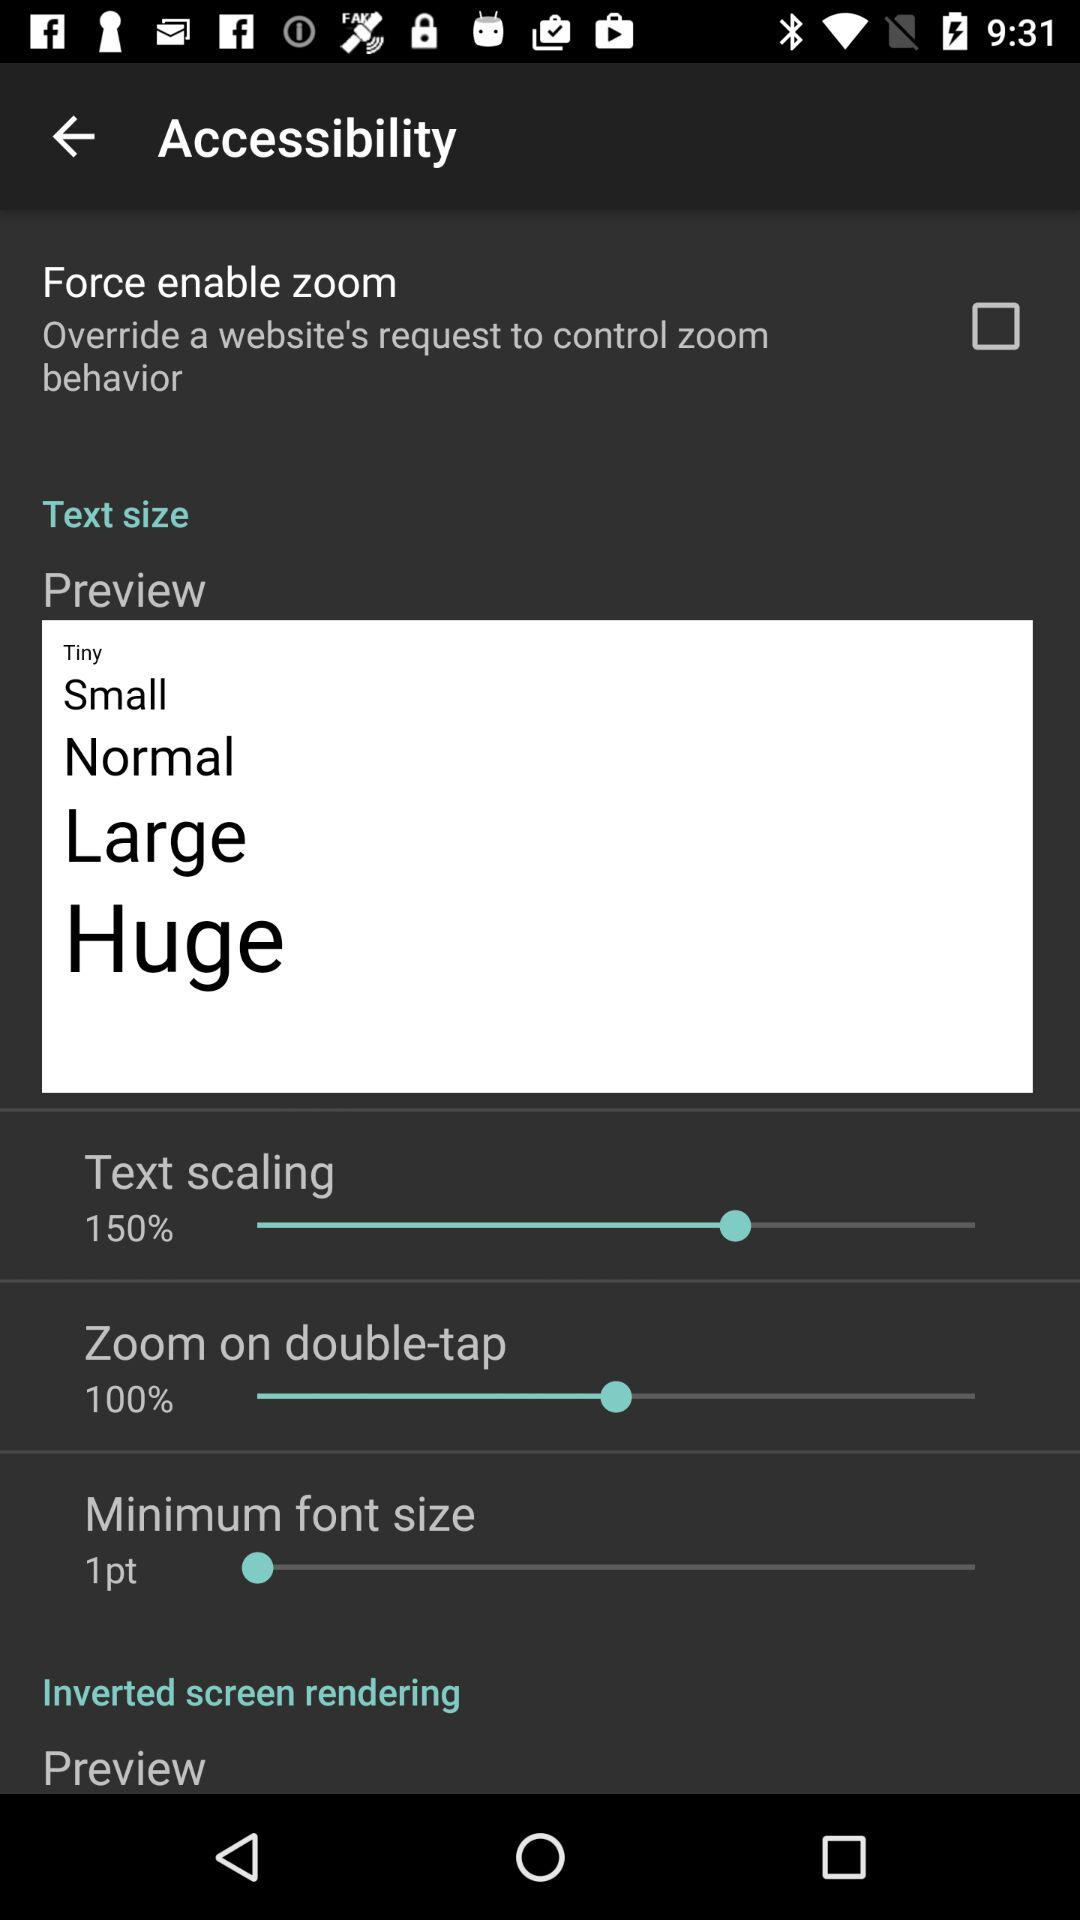What is the minimum font size? The minimum font size is 1 point. 